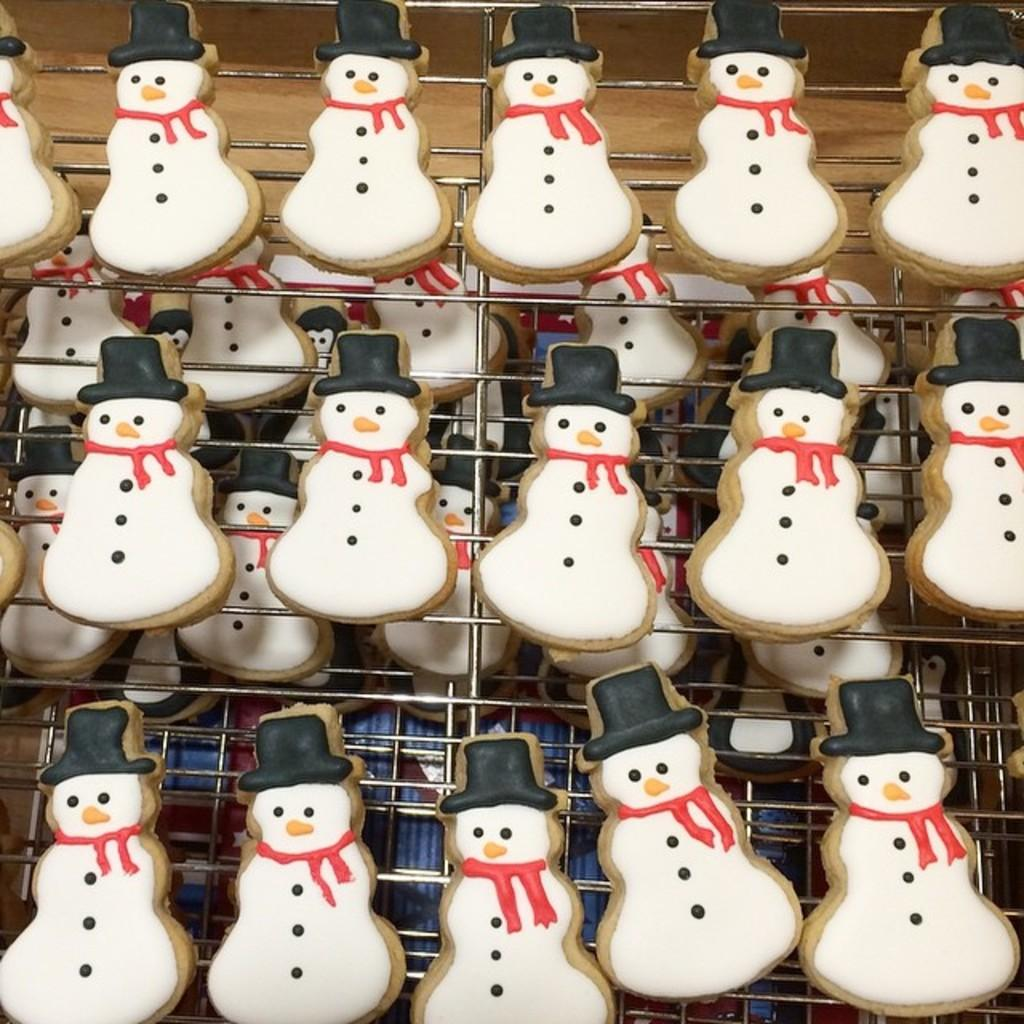What type of toys are present in the image? There is a group of snowman toys in the image. How many snowman toys are in the group? The number of snowman toys is not specified in the provided facts, so it cannot be determined from the image. What is the setting or environment of the image? The setting or environment of the image is not specified in the provided facts, so it cannot be determined from the image. What plot of land does the father own in the image? There is no father or plot of land present in the image; it features a group of snowman toys. 